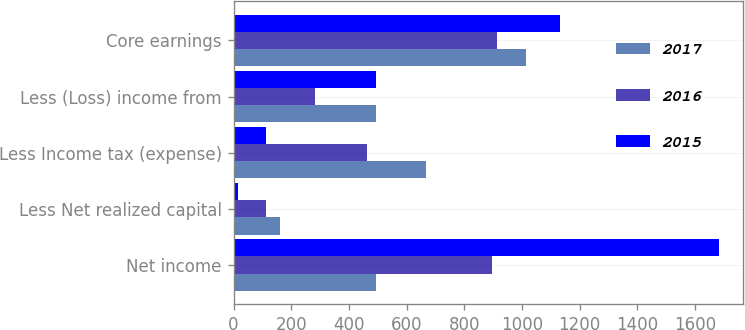<chart> <loc_0><loc_0><loc_500><loc_500><stacked_bar_chart><ecel><fcel>Net income<fcel>Less Net realized capital<fcel>Less Income tax (expense)<fcel>Less (Loss) income from<fcel>Core earnings<nl><fcel>2017<fcel>493<fcel>160<fcel>669<fcel>493<fcel>1014<nl><fcel>2016<fcel>896<fcel>112<fcel>463<fcel>283<fcel>912<nl><fcel>2015<fcel>1682<fcel>15<fcel>114<fcel>493<fcel>1131<nl></chart> 